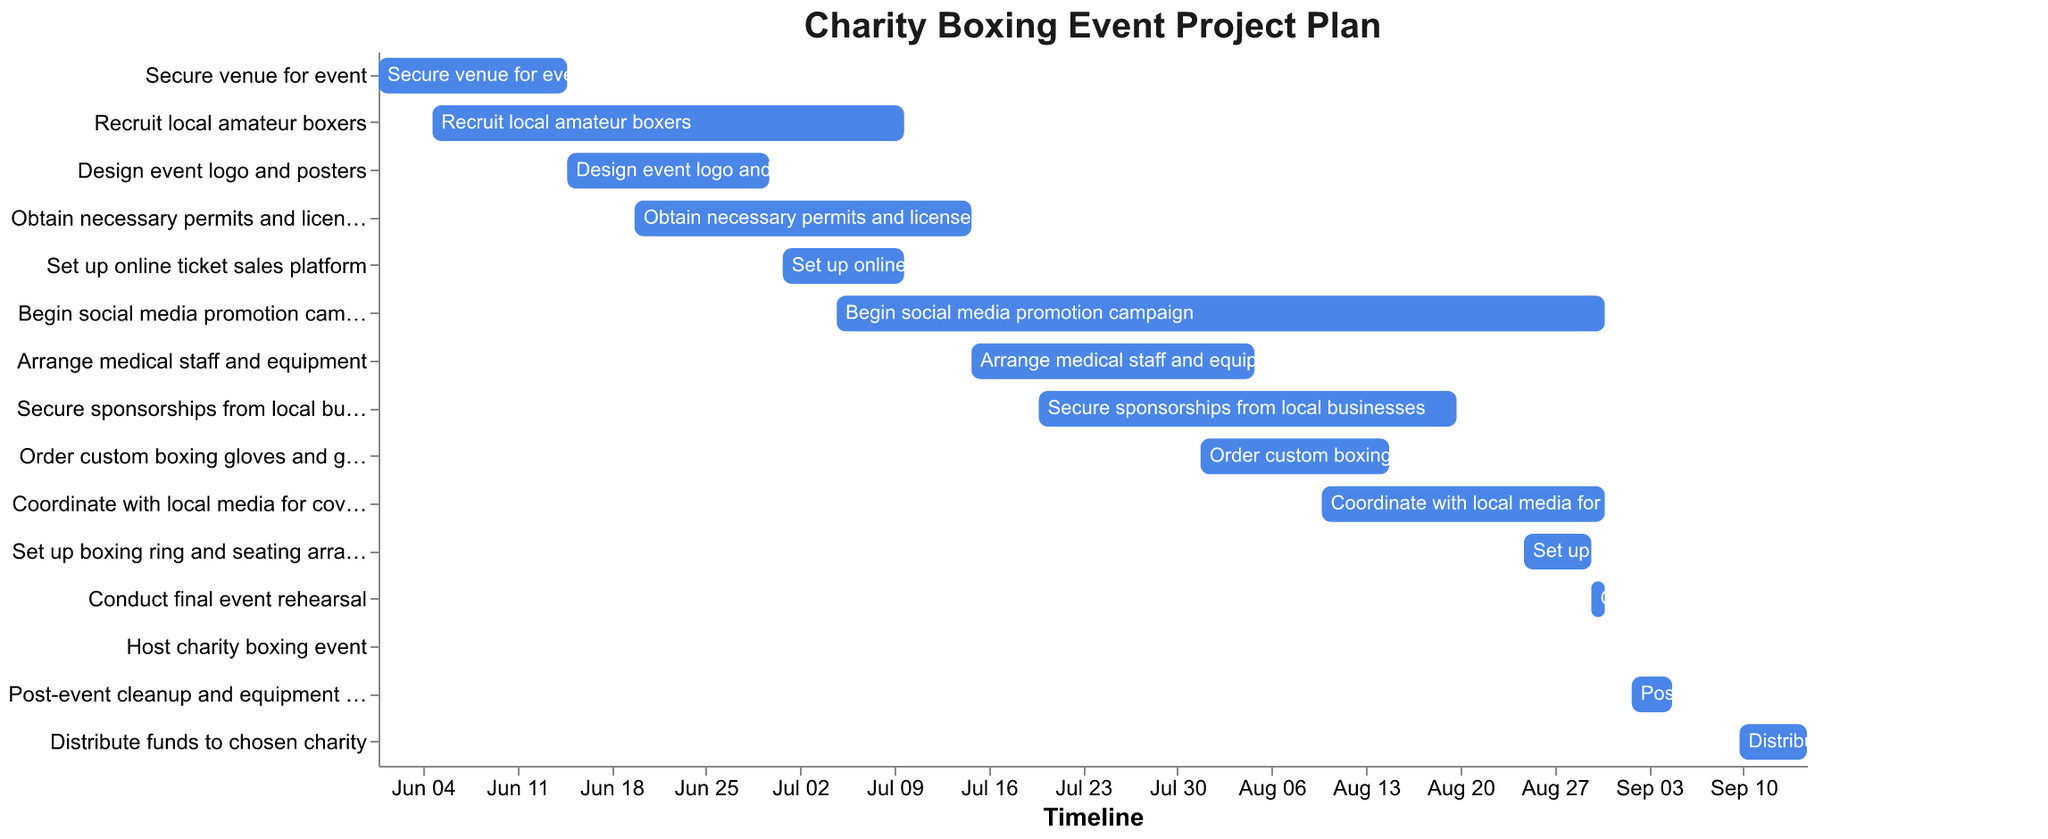What's the title of the figure? The title is usually placed at the top of the chart and is designed to give a summary of what the chart is about. By looking at the top of the Gantt Chart, we can identify the title.
Answer: Charity Boxing Event Project Plan What is the time span of the project? To determine the time span, look at the timeline marked on the x-axis and note the earliest start date and the latest end date. The project starts on June 1, 2023, and ends on September 15, 2023.
Answer: June 1, 2023 - September 15, 2023 Which task has the shortest duration? To find the shortest duration, observe the lengths of the horizontal bars. The task with the shortest bar is the one we’re looking for. The "Host charity boxing event" task spans only one day.
Answer: Host charity boxing event How long does "Secure venue for event" take compared to "Design event logo and posters"? Locate both tasks on the y-axis and note their start and end dates. "Secure venue for event" runs from June 1 to June 15 (15 days) and "Design event logo and posters" runs from June 15 to June 30 (15 days). Both tasks take the same amount of time.
Answer: Both take 15 days When does the social media promotion campaign start and end? Find the "Begin social media promotion campaign" task on the y-axis, and then trace the corresponding bar to note its start and end dates.
Answer: July 5, 2023, to August 31, 2023 Which tasks are scheduled to be completed in August? Identify the tasks whose end dates fall within the month of August. These tasks are "Arrange medical staff and equipment" (August 5), "Order custom boxing gloves and gear" (August 15), "Secure sponsorships from local businesses" (August 20), and "Coordinate with local media for coverage" (August 31).
Answer: Arrange medical staff and equipment, Order custom boxing gloves and gear, Secure sponsorships from local businesses, Coordinate with local media for coverage Which tasks overlap with "Obtain necessary permits and licenses"? To determine overlap, compare the timeline of "Obtain necessary permits and licenses" (June 20 to July 15) with other tasks. Overlapping tasks include "Recruit local amateur boxers" (June 5 to July 10), "Design event logo and posters" (June 15 to June 30), and "Set up online ticket sales platform" (July 1 to July 10).
Answer: Recruit local amateur boxers, Design event logo and posters, Set up online ticket sales platform What is the sequence of tasks in the last week of August? Examine the tasks and their timelines to see which ones fall within the last week of August (August 25-31). The tasks are "Set up boxing ring and seating arrangements" (August 25-30), "Conduct final event rehearsal" (August 30-31), and "Coordinate with local media for coverage" (August 10-31).
Answer: Set up boxing ring and seating arrangements, Conduct final event rehearsal, Coordinate with local media for coverage When is the post-event cleanup and equipment return scheduled? Locate the "Post-event cleanup and equipment return" task on the y-axis and trace the corresponding bar to note its start and end dates.
Answer: September 2, 2023, to September 5, 2023 What is the overlap duration between "Conduct final event rehearsal" and "Coordinate with local media for coverage"? "Conduct final event rehearsal" runs from August 30 to August 31 and "Coordinate with local media for coverage" runs from August 10 to August 31. To find the overlap, note the common period, which is August 30-31—2 days.
Answer: 2 days 